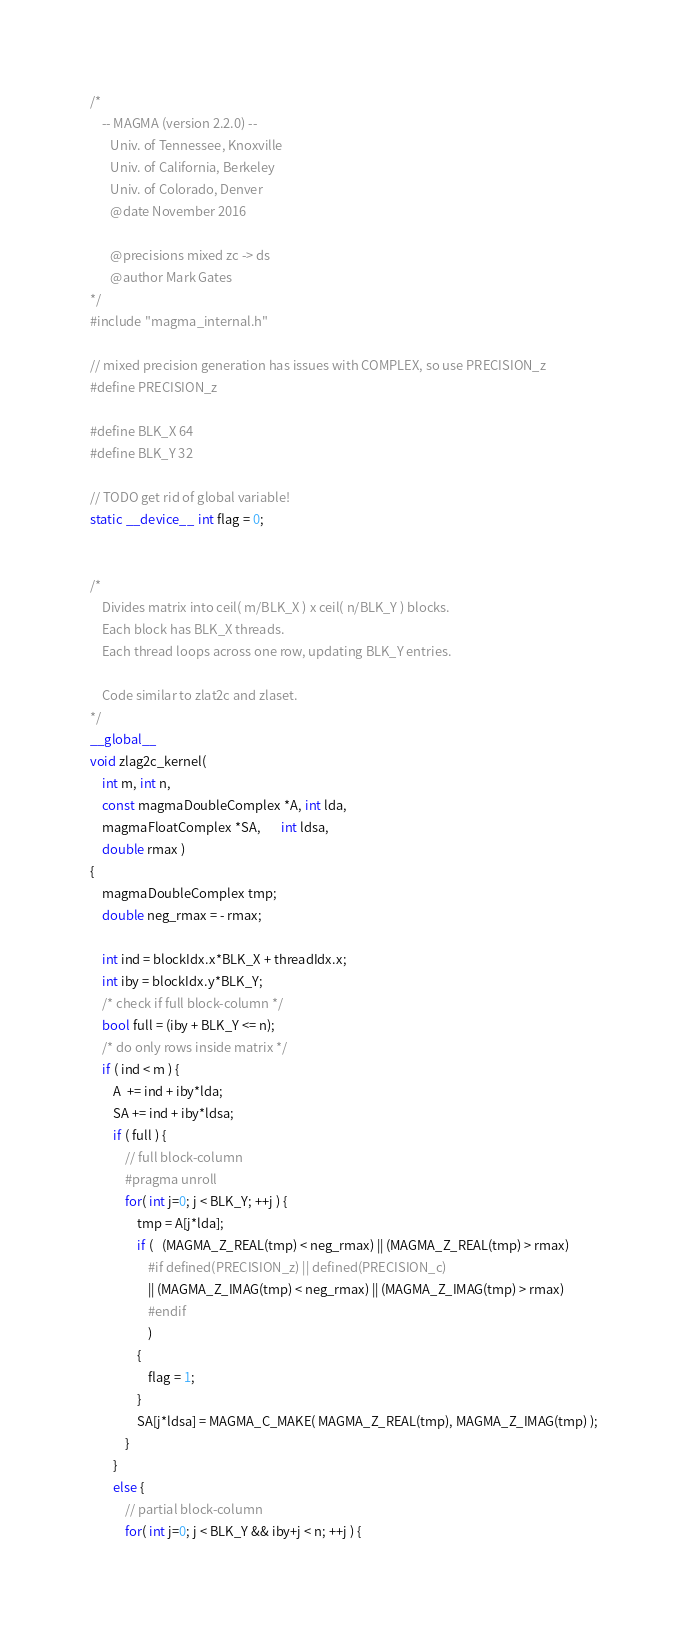<code> <loc_0><loc_0><loc_500><loc_500><_Cuda_>/*
    -- MAGMA (version 2.2.0) --
       Univ. of Tennessee, Knoxville
       Univ. of California, Berkeley
       Univ. of Colorado, Denver
       @date November 2016

       @precisions mixed zc -> ds
       @author Mark Gates
*/
#include "magma_internal.h"

// mixed precision generation has issues with COMPLEX, so use PRECISION_z
#define PRECISION_z

#define BLK_X 64
#define BLK_Y 32

// TODO get rid of global variable!
static __device__ int flag = 0;


/*
    Divides matrix into ceil( m/BLK_X ) x ceil( n/BLK_Y ) blocks.
    Each block has BLK_X threads.
    Each thread loops across one row, updating BLK_Y entries.
    
    Code similar to zlat2c and zlaset.
*/
__global__
void zlag2c_kernel(
    int m, int n,
    const magmaDoubleComplex *A, int lda,
    magmaFloatComplex *SA,       int ldsa,
    double rmax )
{
    magmaDoubleComplex tmp;
    double neg_rmax = - rmax;
    
    int ind = blockIdx.x*BLK_X + threadIdx.x;
    int iby = blockIdx.y*BLK_Y;
    /* check if full block-column */
    bool full = (iby + BLK_Y <= n);
    /* do only rows inside matrix */
    if ( ind < m ) {
        A  += ind + iby*lda;
        SA += ind + iby*ldsa;
        if ( full ) {
            // full block-column
            #pragma unroll
            for( int j=0; j < BLK_Y; ++j ) {
                tmp = A[j*lda];
                if (   (MAGMA_Z_REAL(tmp) < neg_rmax) || (MAGMA_Z_REAL(tmp) > rmax)
                    #if defined(PRECISION_z) || defined(PRECISION_c)
                    || (MAGMA_Z_IMAG(tmp) < neg_rmax) || (MAGMA_Z_IMAG(tmp) > rmax)
                    #endif
                    )
                {
                    flag = 1;
                }
                SA[j*ldsa] = MAGMA_C_MAKE( MAGMA_Z_REAL(tmp), MAGMA_Z_IMAG(tmp) );
            }
        }
        else {
            // partial block-column
            for( int j=0; j < BLK_Y && iby+j < n; ++j ) {</code> 